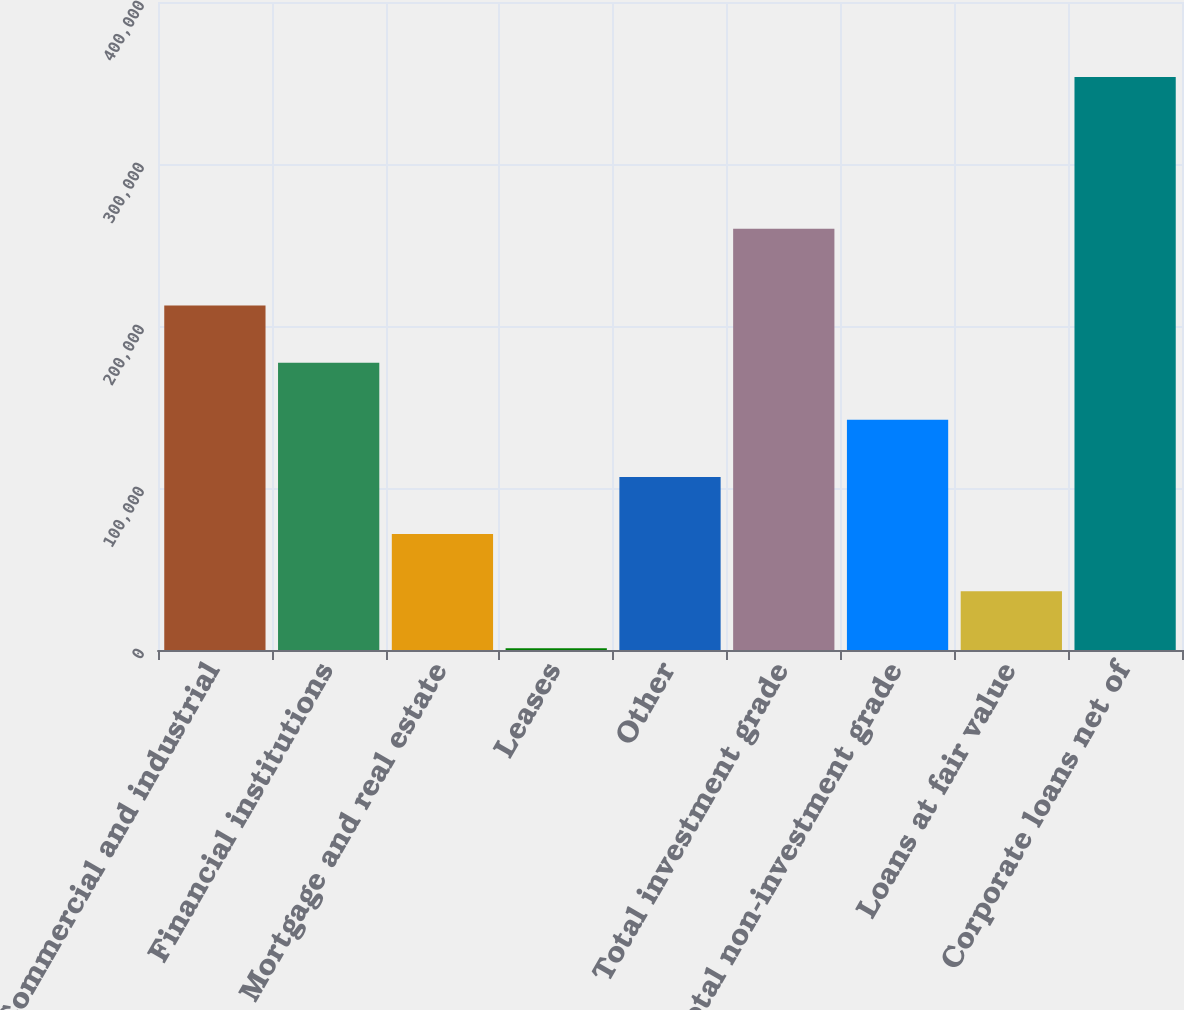Convert chart to OTSL. <chart><loc_0><loc_0><loc_500><loc_500><bar_chart><fcel>Commercial and industrial<fcel>Financial institutions<fcel>Mortgage and real estate<fcel>Leases<fcel>Other<fcel>Total investment grade<fcel>Total non-investment grade<fcel>Loans at fair value<fcel>Corporate loans net of<nl><fcel>212640<fcel>177372<fcel>71570.6<fcel>1036<fcel>106838<fcel>259992<fcel>142105<fcel>36303.3<fcel>353709<nl></chart> 